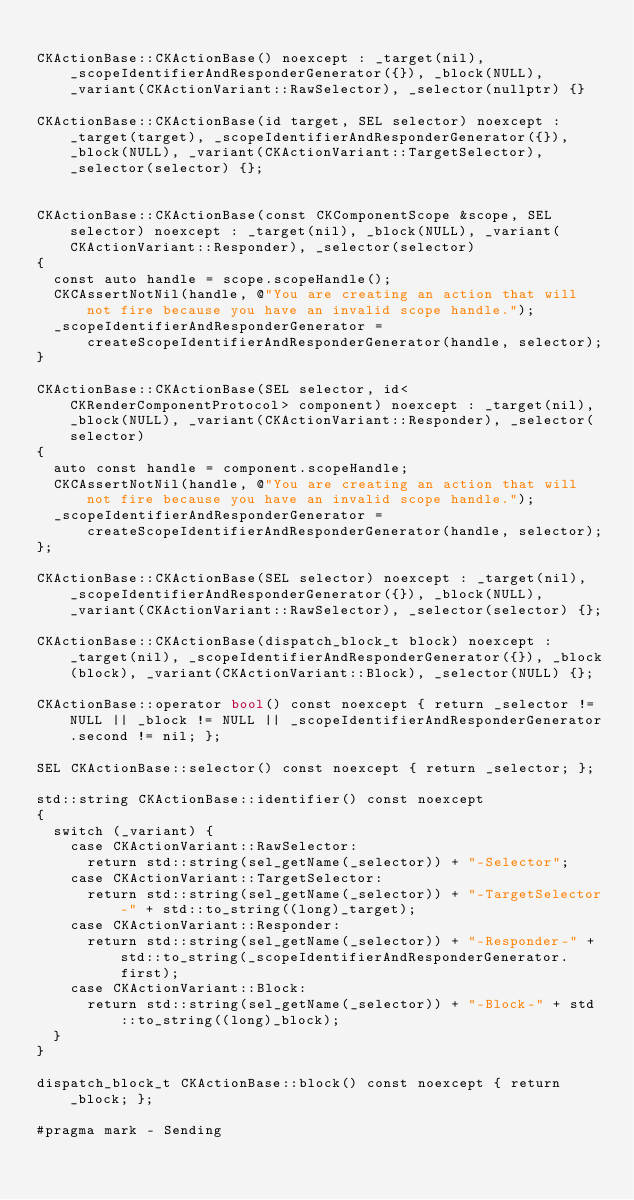Convert code to text. <code><loc_0><loc_0><loc_500><loc_500><_ObjectiveC_>
CKActionBase::CKActionBase() noexcept : _target(nil), _scopeIdentifierAndResponderGenerator({}), _block(NULL), _variant(CKActionVariant::RawSelector), _selector(nullptr) {}

CKActionBase::CKActionBase(id target, SEL selector) noexcept : _target(target), _scopeIdentifierAndResponderGenerator({}), _block(NULL), _variant(CKActionVariant::TargetSelector), _selector(selector) {};


CKActionBase::CKActionBase(const CKComponentScope &scope, SEL selector) noexcept : _target(nil), _block(NULL), _variant(CKActionVariant::Responder), _selector(selector)
{
  const auto handle = scope.scopeHandle();
  CKCAssertNotNil(handle, @"You are creating an action that will not fire because you have an invalid scope handle.");
  _scopeIdentifierAndResponderGenerator = createScopeIdentifierAndResponderGenerator(handle, selector);
}

CKActionBase::CKActionBase(SEL selector, id<CKRenderComponentProtocol> component) noexcept : _target(nil), _block(NULL), _variant(CKActionVariant::Responder), _selector(selector)
{
  auto const handle = component.scopeHandle;
  CKCAssertNotNil(handle, @"You are creating an action that will not fire because you have an invalid scope handle.");
  _scopeIdentifierAndResponderGenerator = createScopeIdentifierAndResponderGenerator(handle, selector);
};

CKActionBase::CKActionBase(SEL selector) noexcept : _target(nil), _scopeIdentifierAndResponderGenerator({}), _block(NULL), _variant(CKActionVariant::RawSelector), _selector(selector) {};

CKActionBase::CKActionBase(dispatch_block_t block) noexcept : _target(nil), _scopeIdentifierAndResponderGenerator({}), _block(block), _variant(CKActionVariant::Block), _selector(NULL) {};

CKActionBase::operator bool() const noexcept { return _selector != NULL || _block != NULL || _scopeIdentifierAndResponderGenerator.second != nil; };

SEL CKActionBase::selector() const noexcept { return _selector; };

std::string CKActionBase::identifier() const noexcept
{
  switch (_variant) {
    case CKActionVariant::RawSelector:
      return std::string(sel_getName(_selector)) + "-Selector";
    case CKActionVariant::TargetSelector:
      return std::string(sel_getName(_selector)) + "-TargetSelector-" + std::to_string((long)_target);
    case CKActionVariant::Responder:
      return std::string(sel_getName(_selector)) + "-Responder-" + std::to_string(_scopeIdentifierAndResponderGenerator.first);
    case CKActionVariant::Block:
      return std::string(sel_getName(_selector)) + "-Block-" + std::to_string((long)_block);
  }
}

dispatch_block_t CKActionBase::block() const noexcept { return _block; };

#pragma mark - Sending
</code> 